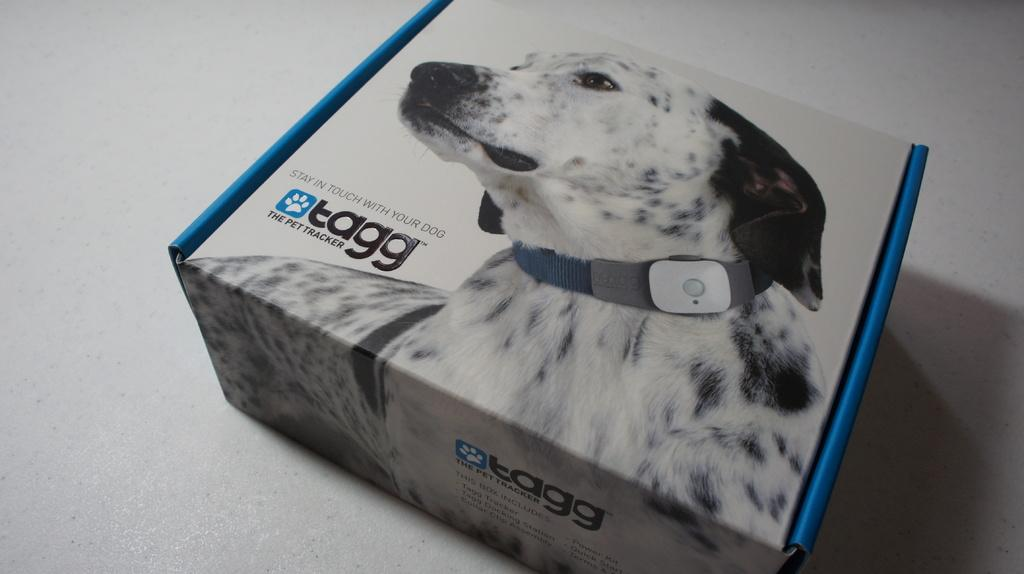<image>
Describe the image concisely. An electronic dog leash made by the brand Tagg. 